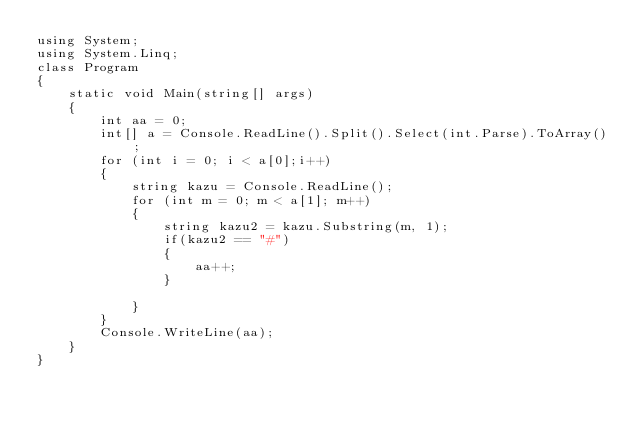Convert code to text. <code><loc_0><loc_0><loc_500><loc_500><_C#_>using System;
using System.Linq;
class Program
{
    static void Main(string[] args)
    {
        int aa = 0;
        int[] a = Console.ReadLine().Split().Select(int.Parse).ToArray();
        for (int i = 0; i < a[0];i++)
        {
            string kazu = Console.ReadLine();
            for (int m = 0; m < a[1]; m++)
            {
                string kazu2 = kazu.Substring(m, 1);
                if(kazu2 == "#")
                {
                    aa++;
                }

            }
        }
        Console.WriteLine(aa);
    }
}</code> 